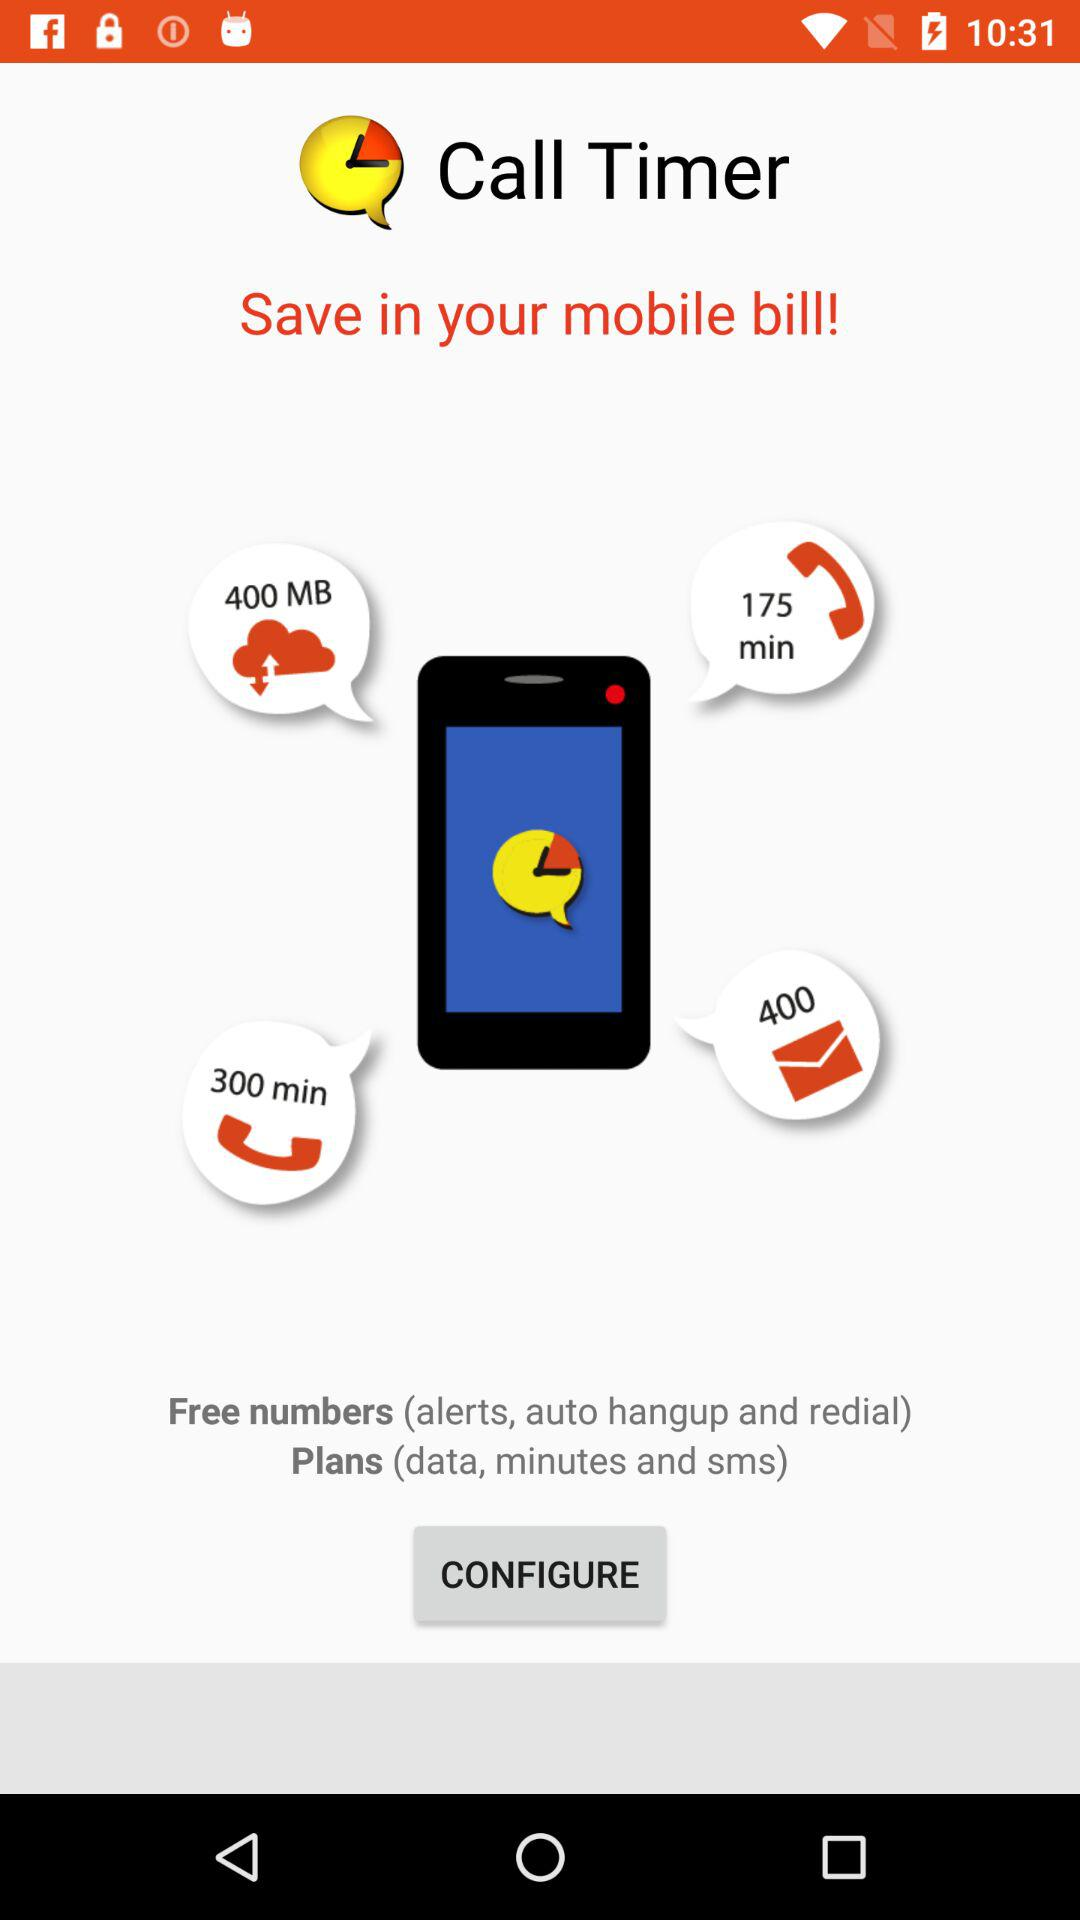How many more MB of data are included in the 400 MB plan than the 300 MB plan?
Answer the question using a single word or phrase. 100 